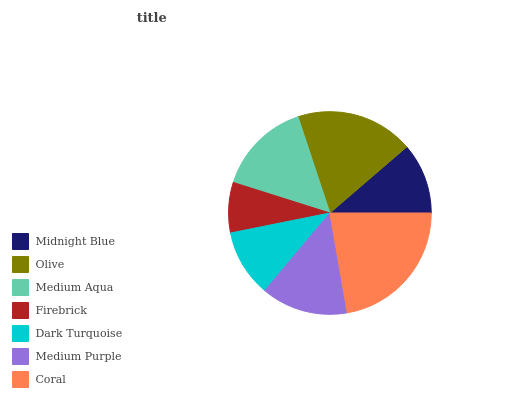Is Firebrick the minimum?
Answer yes or no. Yes. Is Coral the maximum?
Answer yes or no. Yes. Is Olive the minimum?
Answer yes or no. No. Is Olive the maximum?
Answer yes or no. No. Is Olive greater than Midnight Blue?
Answer yes or no. Yes. Is Midnight Blue less than Olive?
Answer yes or no. Yes. Is Midnight Blue greater than Olive?
Answer yes or no. No. Is Olive less than Midnight Blue?
Answer yes or no. No. Is Medium Purple the high median?
Answer yes or no. Yes. Is Medium Purple the low median?
Answer yes or no. Yes. Is Firebrick the high median?
Answer yes or no. No. Is Firebrick the low median?
Answer yes or no. No. 